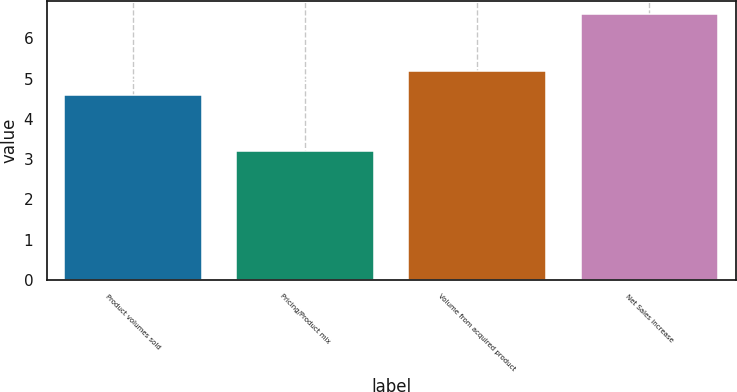Convert chart to OTSL. <chart><loc_0><loc_0><loc_500><loc_500><bar_chart><fcel>Product volumes sold<fcel>Pricing/Product mix<fcel>Volume from acquired product<fcel>Net Sales increase<nl><fcel>4.6<fcel>3.2<fcel>5.2<fcel>6.6<nl></chart> 